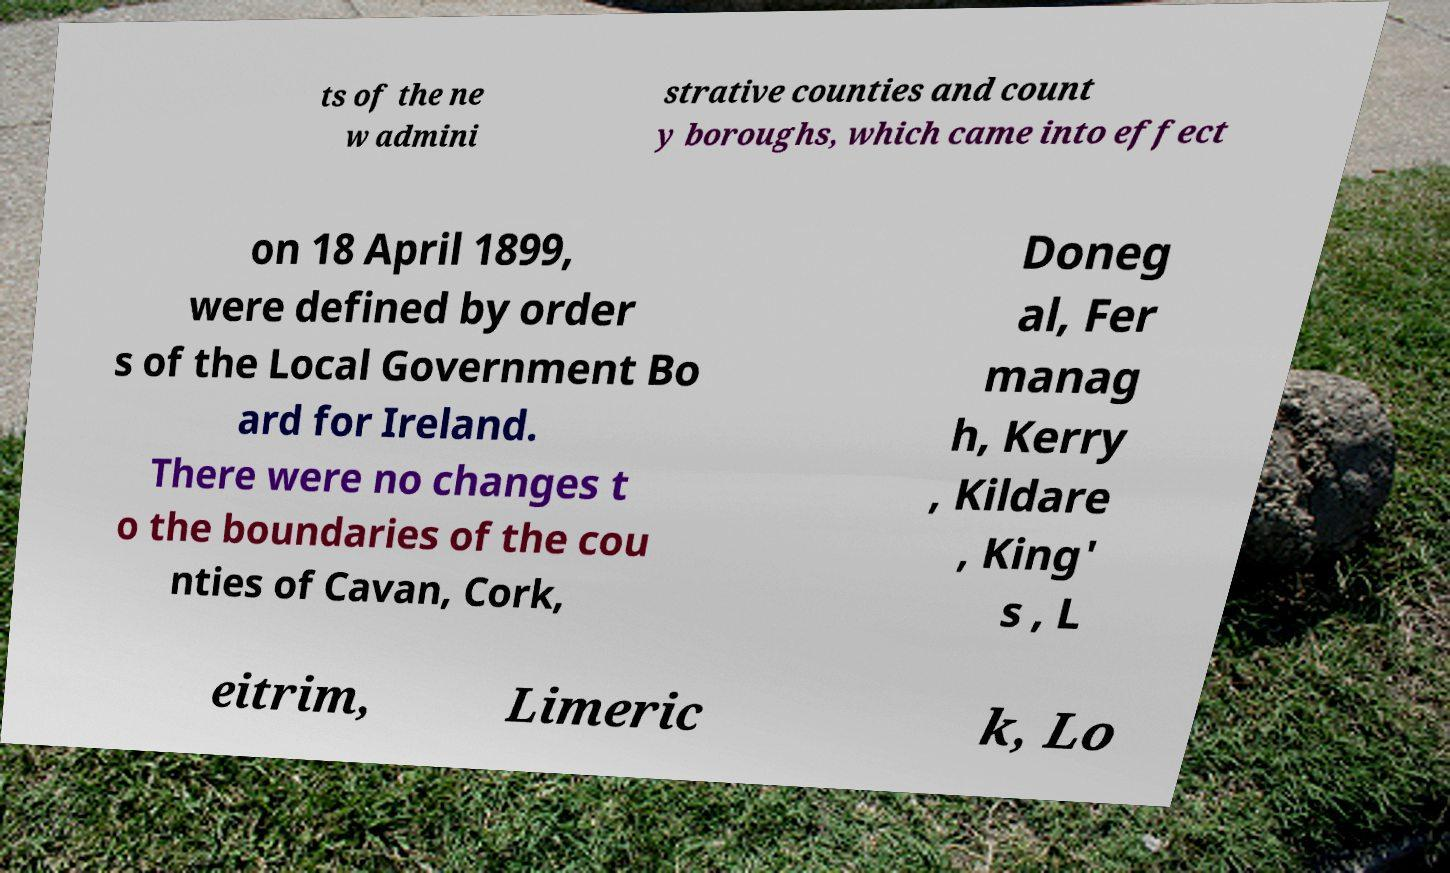Could you extract and type out the text from this image? ts of the ne w admini strative counties and count y boroughs, which came into effect on 18 April 1899, were defined by order s of the Local Government Bo ard for Ireland. There were no changes t o the boundaries of the cou nties of Cavan, Cork, Doneg al, Fer manag h, Kerry , Kildare , King' s , L eitrim, Limeric k, Lo 